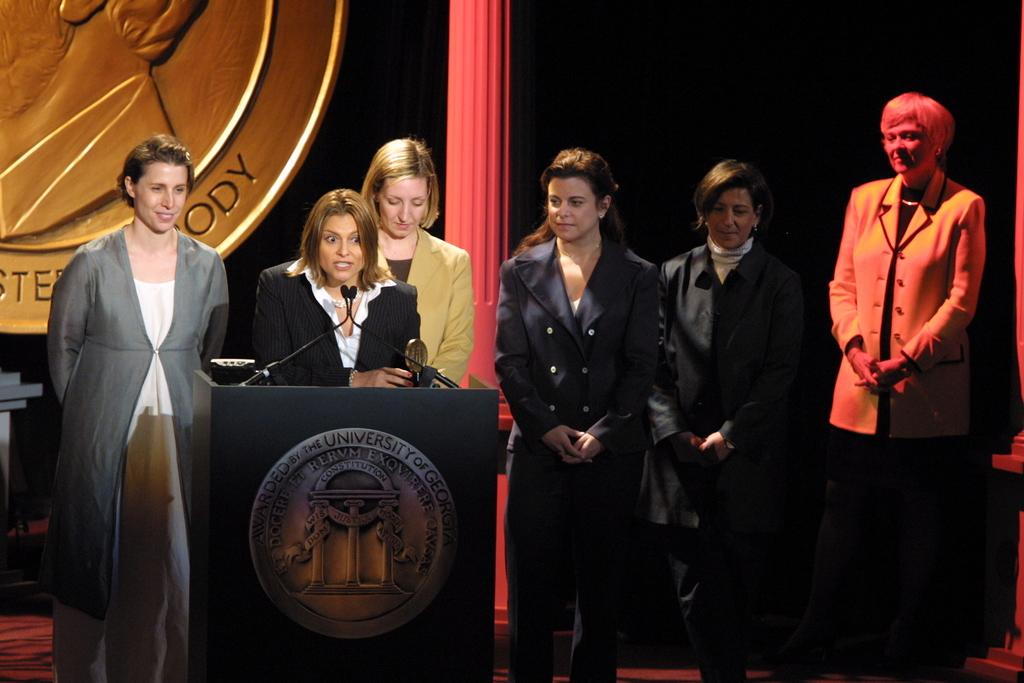What structure is located in the center of the image? There is a podium in the image. What feature can be seen on the podium? There are lights on the podium. Who or what is in front of the podium? There are people in front of the podium. What is located behind the podium? There is a pole behind the podium. How would you describe the overall lighting in the image? The background of the image is dark. What color is the family's wall in the image? There is no family or wall present in the image; it features a podium with lights, people in front of it, a pole behind it, and a dark background. 